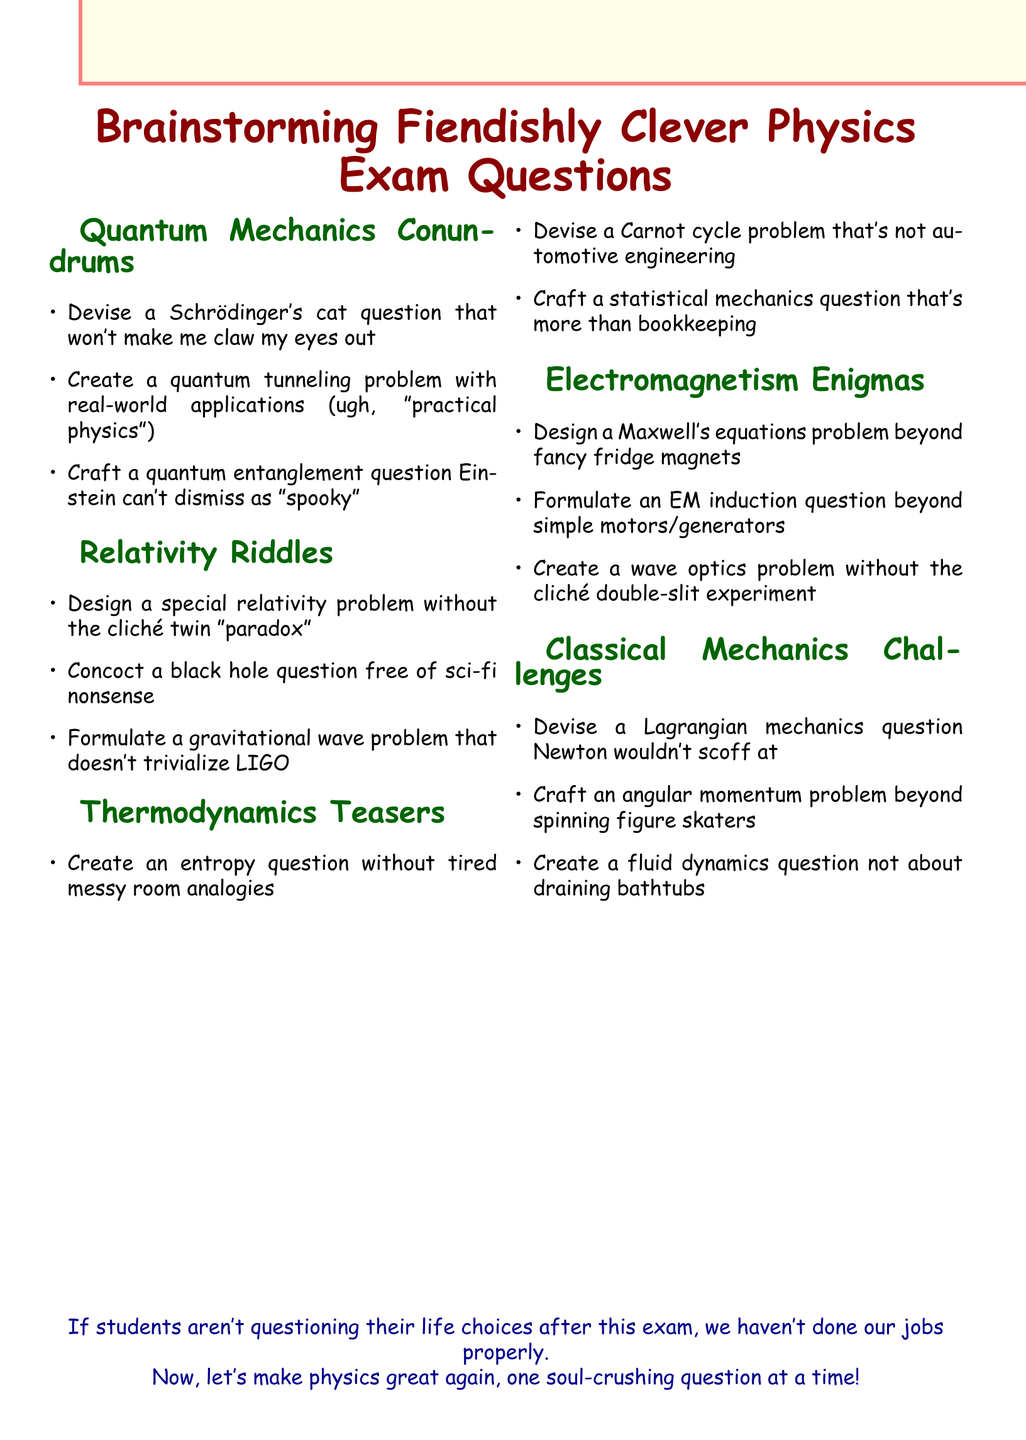What is the title of the document? The title, prominently displayed at the top, details the subject of the notes.
Answer: Brainstorming Fiendishly Clever Physics Exam Questions How many sections are in the document? The document clearly lists its sections, providing a count of the distinct areas covered.
Answer: Five What is the first topic covered in the sections? The first section heading indicates the initial area of focus in the document.
Answer: Quantum Mechanics Conundrums Name a specific concept mentioned in the Thermodynamics Teasers section. Each section lists key topics; one can find specific concepts within the mentioned section.
Answer: Entropy What does the conclusion suggest about students' feelings after the exam? The concluding statement reflects a sentiment aimed at student experience post-exam.
Answer: Questioning their life choices Which problem type is suggested for Maxwell's equations? The points detail specific types of problems to avoid clichés or oversimplifications in various physics domains.
Answer: Beyond fancy refrigerator magnets What is mentioned as a potential theme in the classical mechanics questions? The document emphasizes the need for creativity while avoiding conventional scenarios in classical mechanics.
Answer: Not about draining bathtubs Which Einstein-related concept is referenced? The document specifically points out a concept associated with Einstein's work to be addressed in the exam.
Answer: Spooky action at a distance What is the tone of the concluding statement? The last statement encompasses the overall mood and intention behind the document’s purpose.
Answer: Sarcastic 